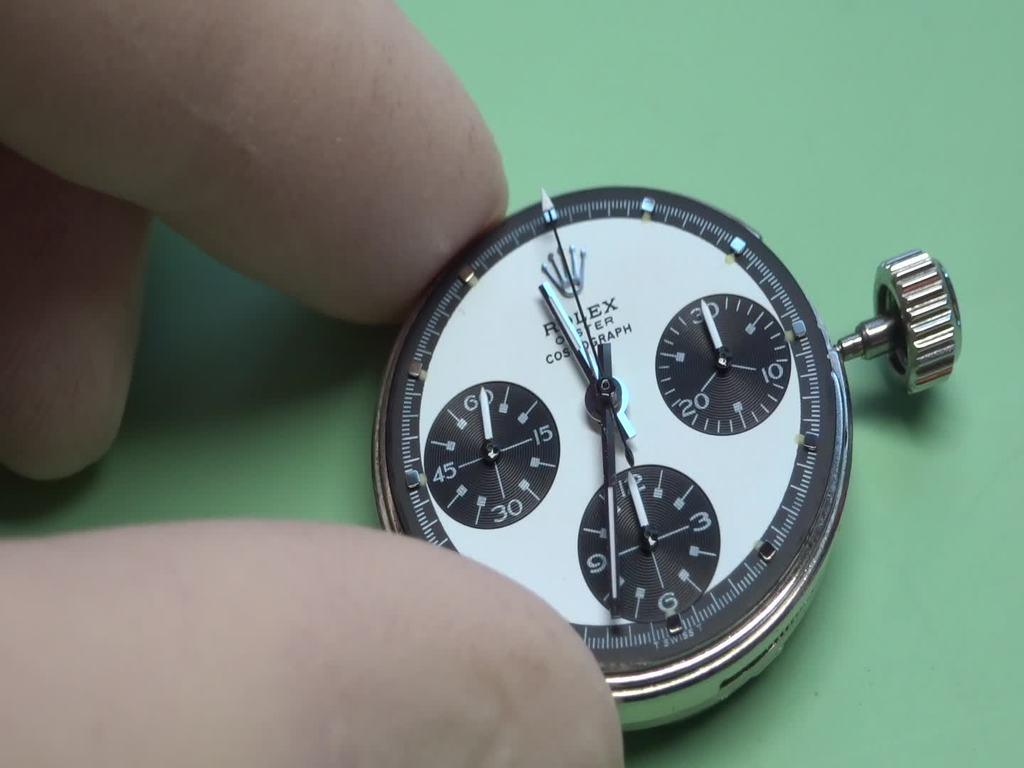<image>
Summarize the visual content of the image. A pesons fingers holding a tiny Rolex stop watch. 